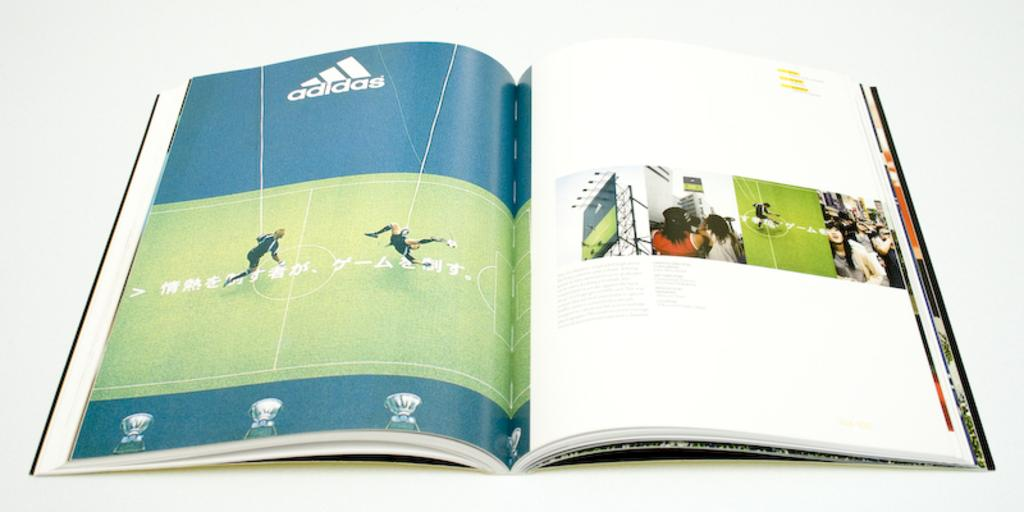<image>
Describe the image concisely. The magazine is open to the ad from Adidas 